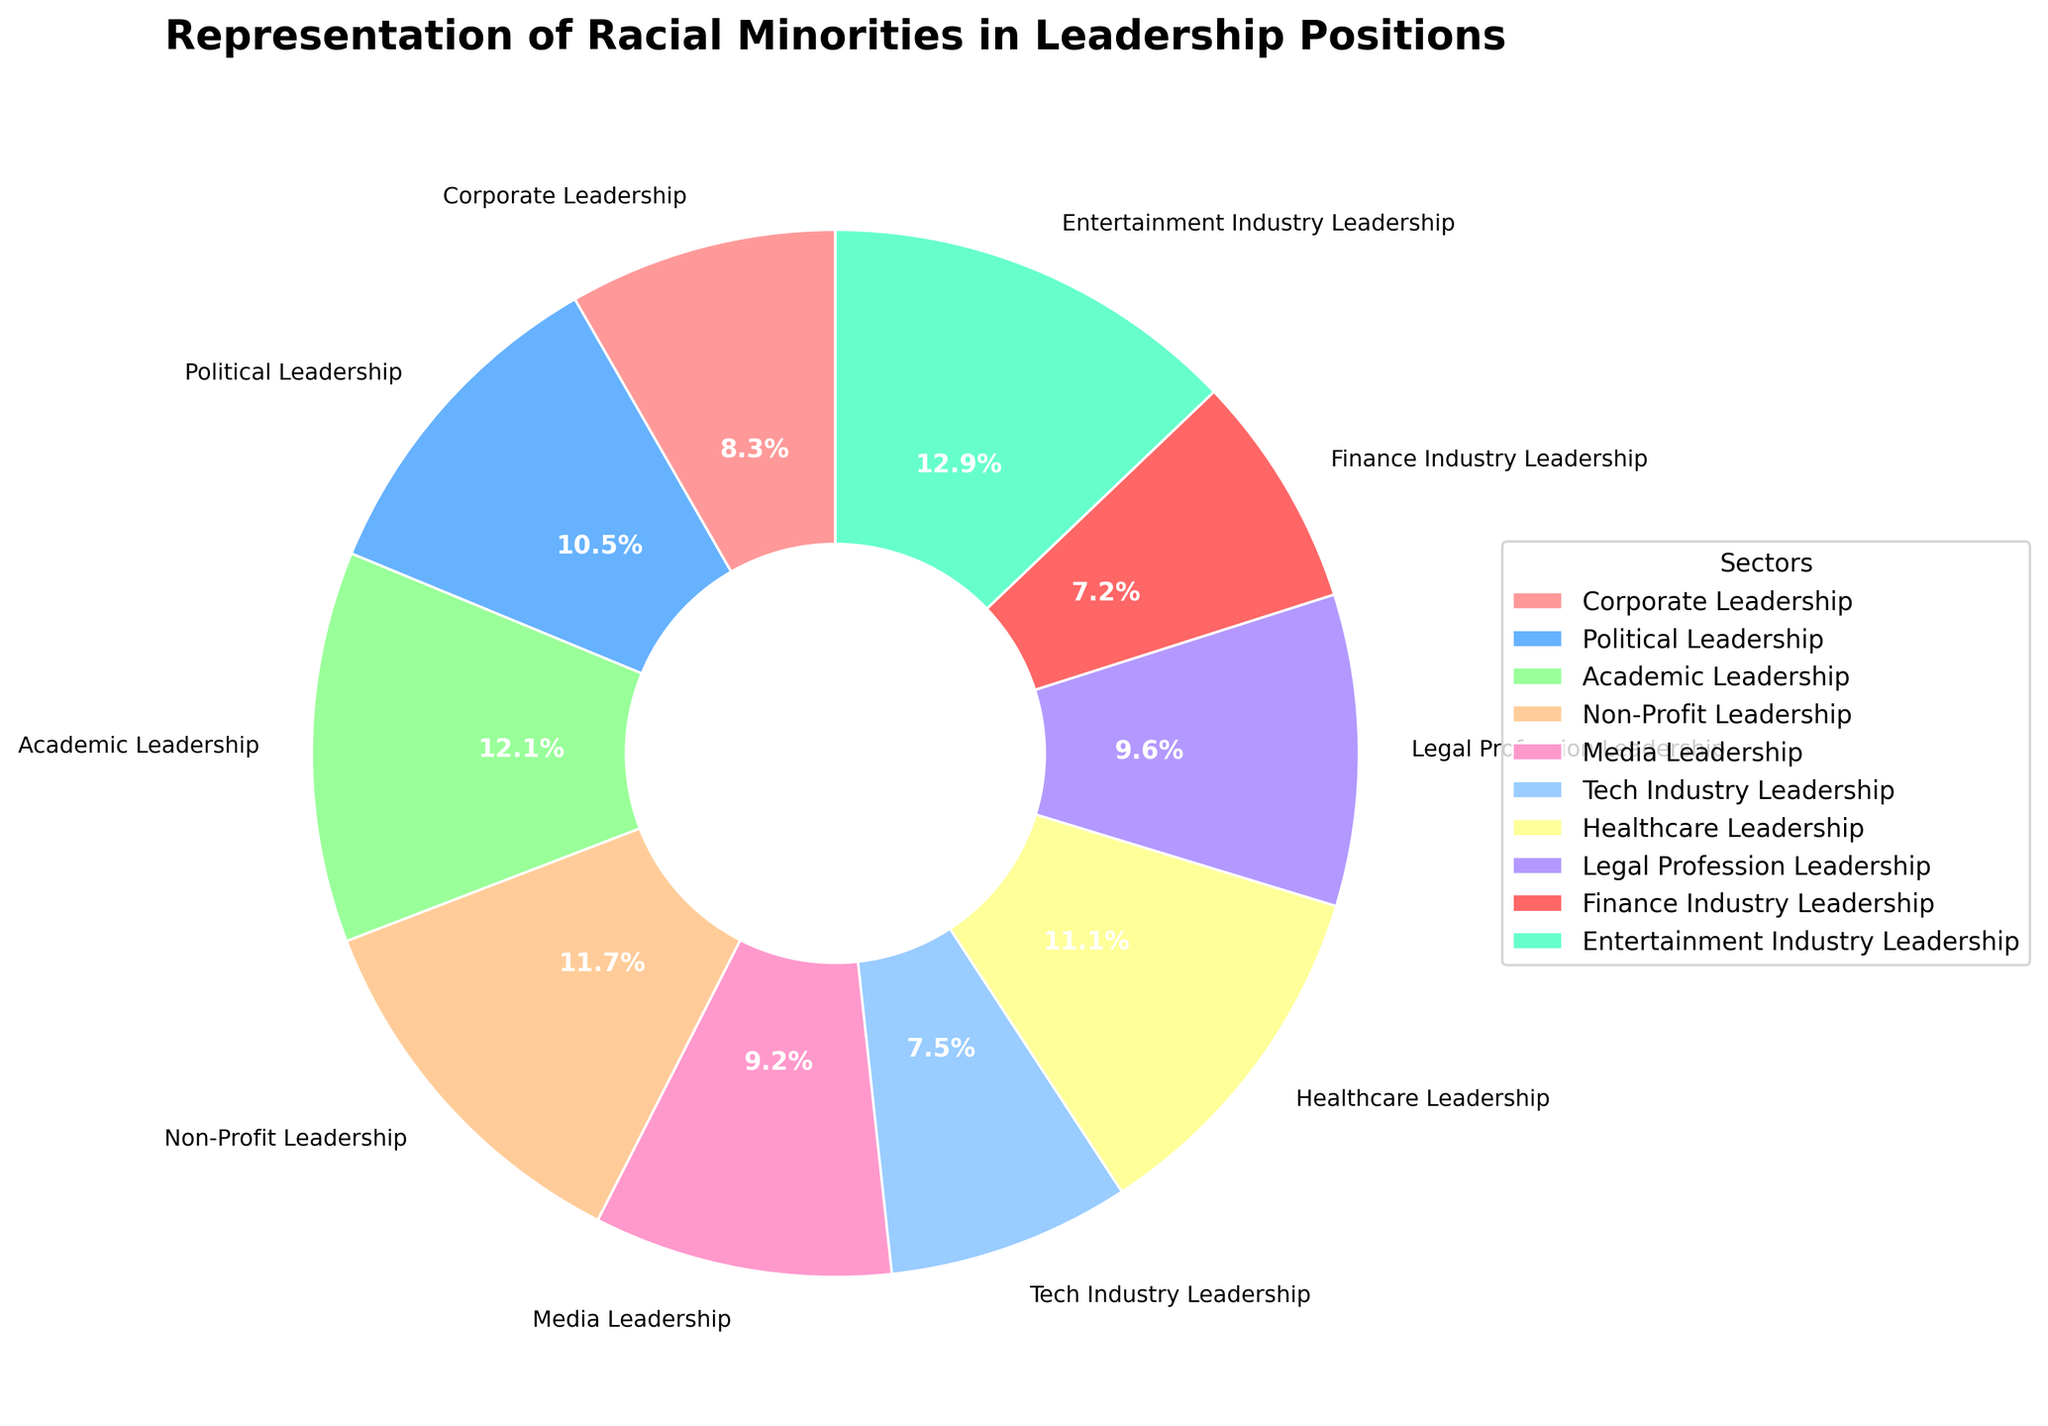Which sector has the highest representation of racial minorities in leadership positions? By looking at the pie chart, the sector with the largest slice or percentage value indicates the highest representation of racial minorities. The Entertainment Industry Leadership has the largest slice at 19.4%.
Answer: Entertainment Industry Leadership What is the combined percentage of racial minorities in the Healthcare and Legal Profession leadership sectors? First, identify the individual percentages for Healthcare Leadership (16.7%) and Legal Profession Leadership (14.5%) from the chart. Then, add them together: 16.7% + 14.5% = 31.2%.
Answer: 31.2% Which two sectors have the closest representation percentages of racial minorities in leadership positions? Compare the percentages on the chart to identify the two sectors with the smallest difference. The closest percentages are Legal Profession Leadership (14.5%) and Media Leadership (13.9%), having a difference of just 0.6%.
Answer: Legal Profession Leadership and Media Leadership How much greater is the representation of racial minorities in Academic Leadership compared to Finance Industry Leadership? Determine the percentages for Academic Leadership (18.2%) and Finance Industry Leadership (10.9%). Subtract the smaller percentage from the larger one: 18.2% - 10.9% = 7.3%.
Answer: 7.3% Which sectors have a representation of racial minorities in leadership positions above 15%? Identify the sectors with percentages greater than 15% from the pie chart: Political Leadership (15.8%), Academic Leadership (18.2%), Non-Profit Leadership (17.6%), Healthcare Leadership (16.7%), and Entertainment Industry Leadership (19.4%).
Answer: Political Leadership, Academic Leadership, Non-Profit Leadership, Healthcare Leadership, Entertainment Industry Leadership What is the average representation of racial minorities in Corporate, Media, and Tech industry leadership sectors? Find the percentages for Corporate Leadership (12.5%), Media Leadership (13.9%), and Tech Industry Leadership (11.3%). Calculate the average: (12.5% + 13.9% + 11.3%) / 3 = 12.566...%
Answer: 12.6% Which sector has the least representation of racial minorities in leadership positions, and what is its percentage? Look for the smallest slice in the pie chart; the Tech Industry Leadership has the least representation at 11.3%.
Answer: Tech Industry Leadership, 11.3% If the total representation of racial minorities in leadership positions is 150%, which sector represents approximately 1/10th of this total? The total representation is 150%. 1/10th of this is 15%. By examining the chart, Political Leadership (15.8%) is close to 15%.
Answer: Political Leadership 